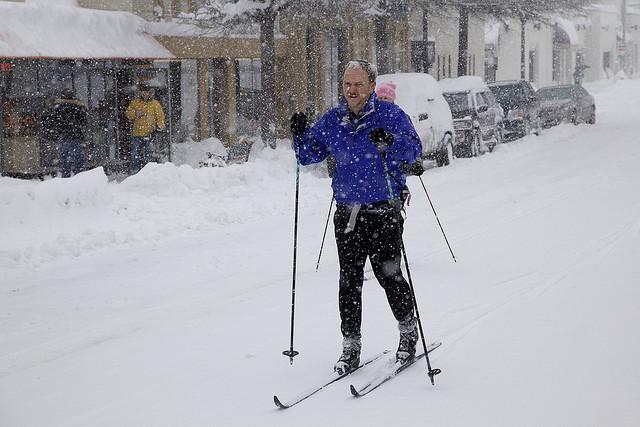Is it normal to ski in the street?
Answer briefly. No. Do they wearing hats?
Answer briefly. No. Is it snowing?
Short answer required. Yes. How many panes in the window?
Be succinct. 4. Is the man wearing any headgear?
Answer briefly. No. Is the man wearing jeans?
Answer briefly. No. How many skiers are there?
Answer briefly. 1. How many vehicles are in the background?
Give a very brief answer. 4. 